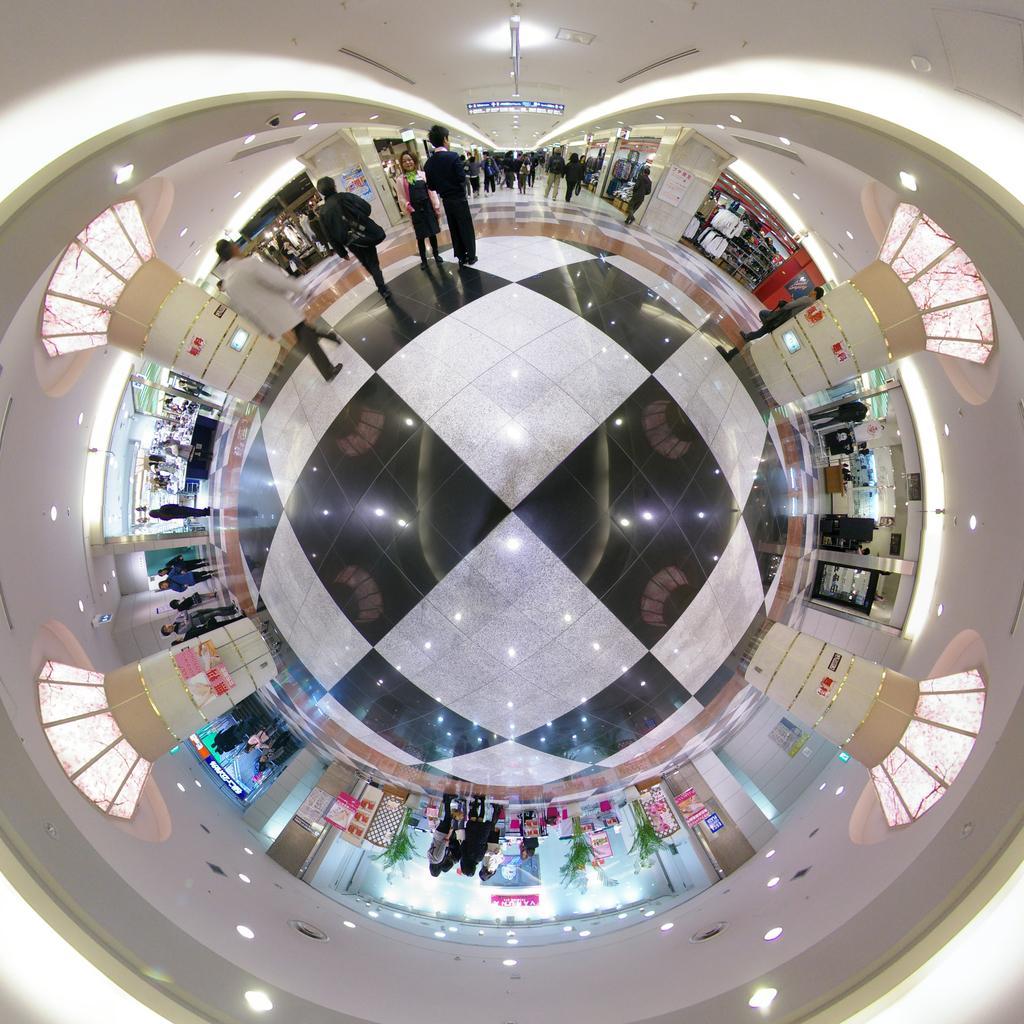Can you describe this image briefly? This image looks like it is edited and checked in a shopping complex. There are many people in this image. And the walls are in white color. 